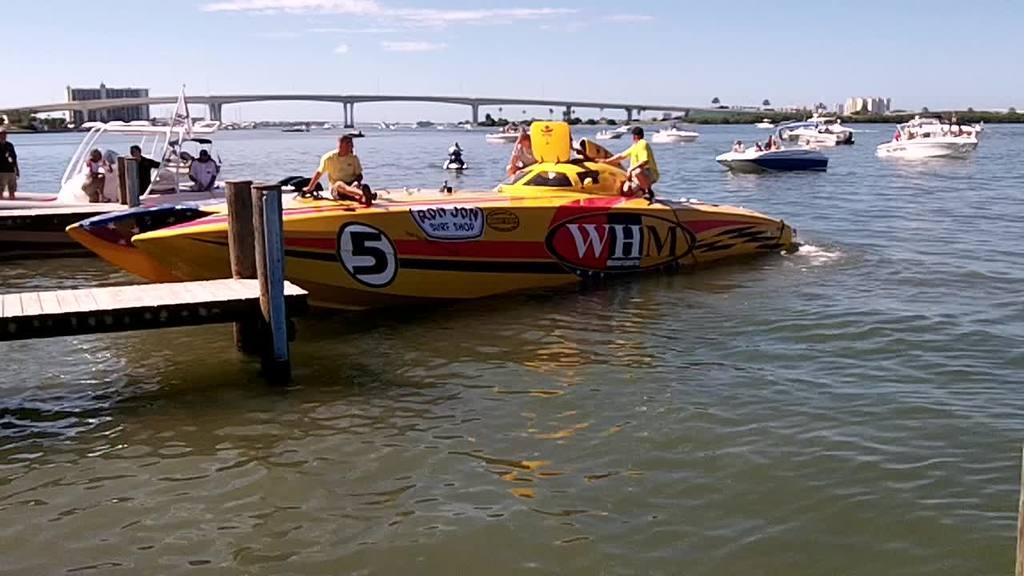Describe this image in one or two sentences. In this picture we can see boats on water and on these boats we can see some people, flag, platform, bridge, buildings, trees and in the background we can see the sky with clouds. 